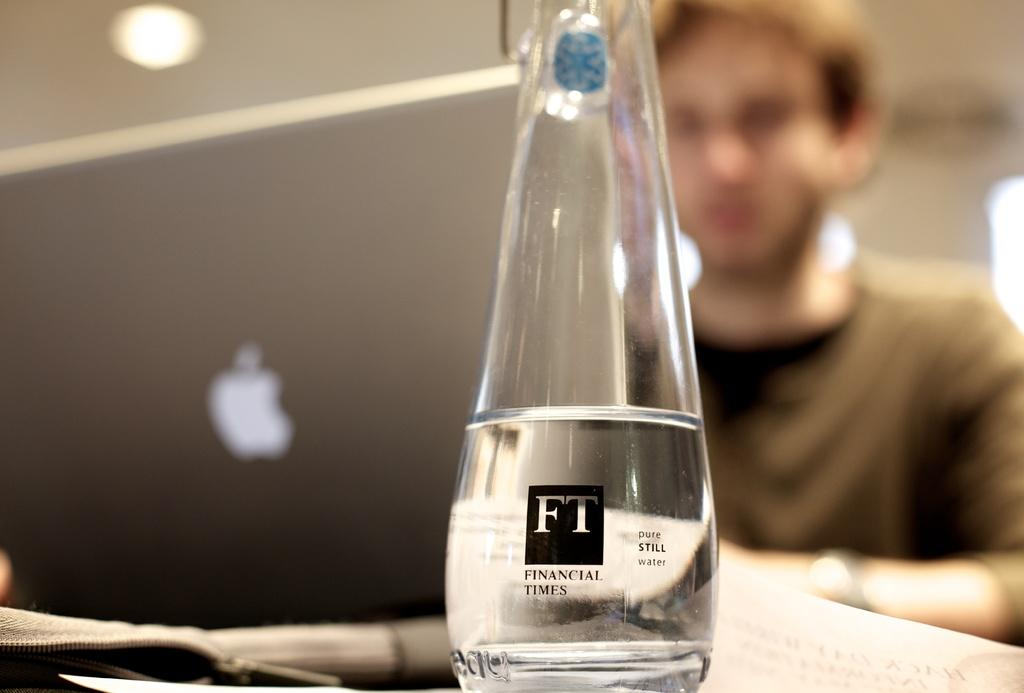Provide a one-sentence caption for the provided image. A glass beaker with liquid on it saying financial times. 